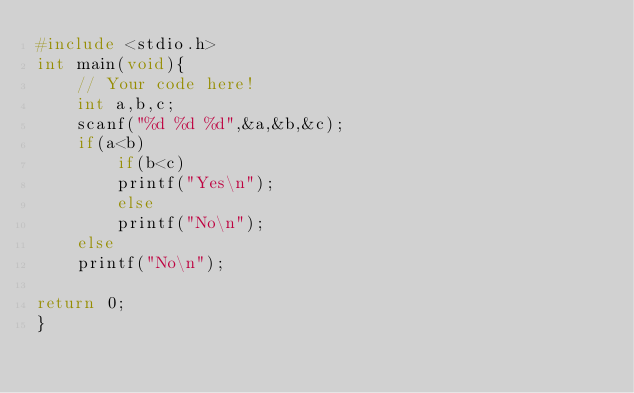Convert code to text. <code><loc_0><loc_0><loc_500><loc_500><_C_>#include <stdio.h>
int main(void){
    // Your code here!
    int a,b,c;
    scanf("%d %d %d",&a,&b,&c);
    if(a<b)
        if(b<c)
        printf("Yes\n");
        else
        printf("No\n");
    else
    printf("No\n");
    
return 0;
}

</code> 